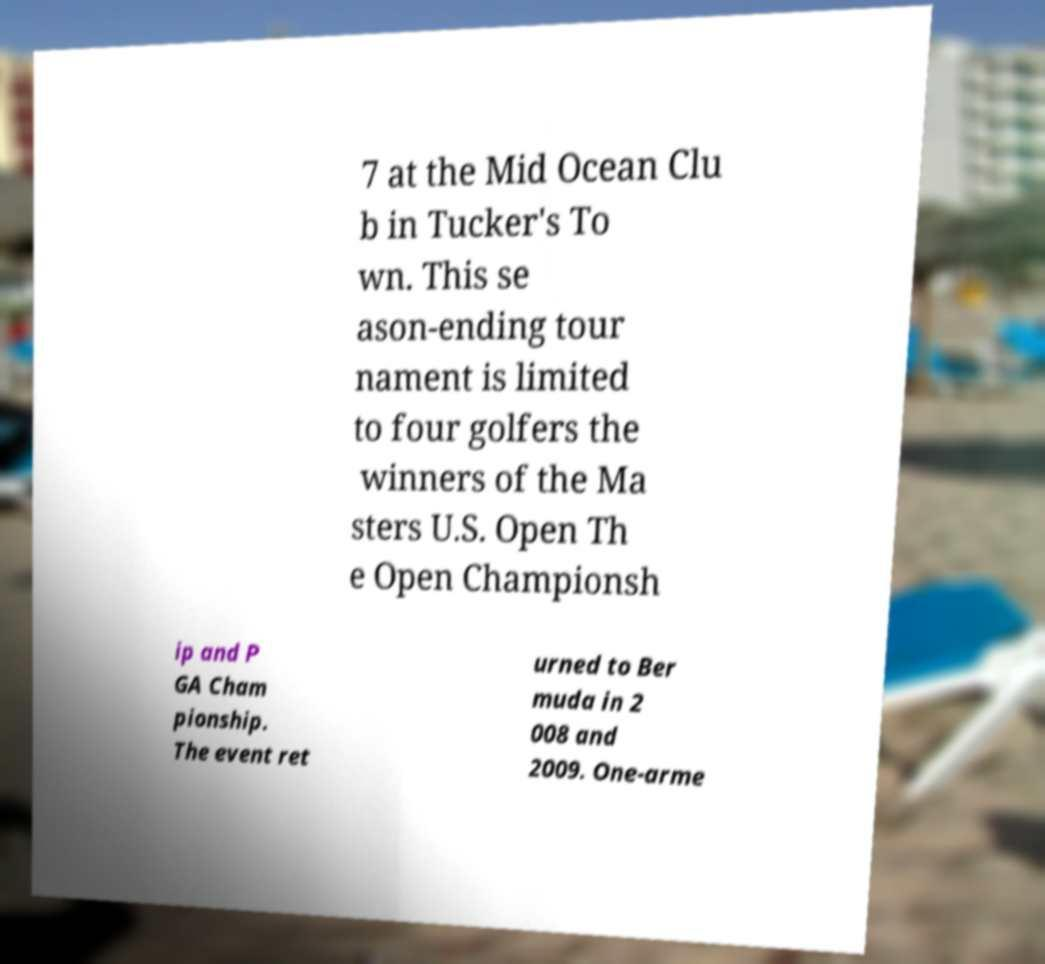What messages or text are displayed in this image? I need them in a readable, typed format. 7 at the Mid Ocean Clu b in Tucker's To wn. This se ason-ending tour nament is limited to four golfers the winners of the Ma sters U.S. Open Th e Open Championsh ip and P GA Cham pionship. The event ret urned to Ber muda in 2 008 and 2009. One-arme 